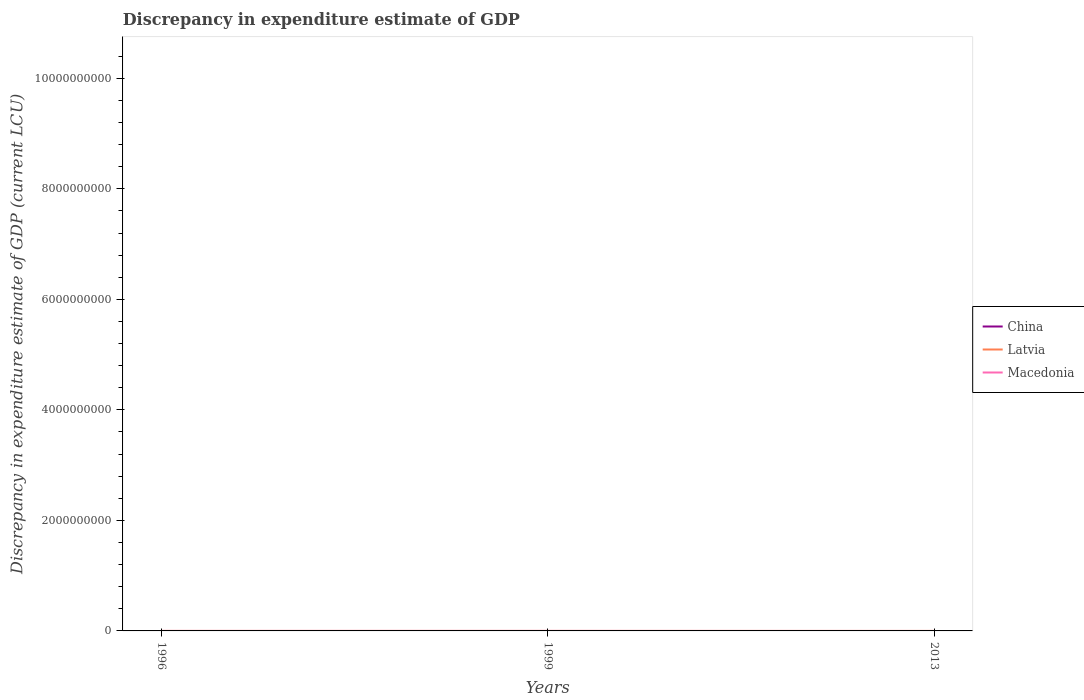How many different coloured lines are there?
Provide a succinct answer. 2. Is the number of lines equal to the number of legend labels?
Provide a short and direct response. No. Across all years, what is the maximum discrepancy in expenditure estimate of GDP in China?
Provide a short and direct response. 0. What is the difference between the highest and the second highest discrepancy in expenditure estimate of GDP in Latvia?
Provide a succinct answer. 1000. What is the difference between the highest and the lowest discrepancy in expenditure estimate of GDP in China?
Provide a succinct answer. 0. How many lines are there?
Give a very brief answer. 2. How many years are there in the graph?
Make the answer very short. 3. Are the values on the major ticks of Y-axis written in scientific E-notation?
Give a very brief answer. No. Does the graph contain any zero values?
Your answer should be very brief. Yes. What is the title of the graph?
Offer a terse response. Discrepancy in expenditure estimate of GDP. Does "Cuba" appear as one of the legend labels in the graph?
Provide a short and direct response. No. What is the label or title of the X-axis?
Your answer should be very brief. Years. What is the label or title of the Y-axis?
Your answer should be very brief. Discrepancy in expenditure estimate of GDP (current LCU). What is the Discrepancy in expenditure estimate of GDP (current LCU) in China in 1996?
Offer a terse response. 0. What is the Discrepancy in expenditure estimate of GDP (current LCU) of Macedonia in 1996?
Ensure brevity in your answer.  0. What is the Discrepancy in expenditure estimate of GDP (current LCU) in China in 1999?
Offer a very short reply. 0. What is the Discrepancy in expenditure estimate of GDP (current LCU) in Latvia in 1999?
Your response must be concise. 1000. What is the Discrepancy in expenditure estimate of GDP (current LCU) in Macedonia in 1999?
Provide a short and direct response. 1.63e+05. What is the Discrepancy in expenditure estimate of GDP (current LCU) in Macedonia in 2013?
Provide a short and direct response. 0. Across all years, what is the maximum Discrepancy in expenditure estimate of GDP (current LCU) of Latvia?
Ensure brevity in your answer.  1000. Across all years, what is the maximum Discrepancy in expenditure estimate of GDP (current LCU) in Macedonia?
Offer a terse response. 1.63e+05. Across all years, what is the minimum Discrepancy in expenditure estimate of GDP (current LCU) of Latvia?
Provide a short and direct response. 0. What is the total Discrepancy in expenditure estimate of GDP (current LCU) of China in the graph?
Ensure brevity in your answer.  0. What is the total Discrepancy in expenditure estimate of GDP (current LCU) in Macedonia in the graph?
Ensure brevity in your answer.  1.63e+05. What is the average Discrepancy in expenditure estimate of GDP (current LCU) in Latvia per year?
Make the answer very short. 333.33. What is the average Discrepancy in expenditure estimate of GDP (current LCU) of Macedonia per year?
Ensure brevity in your answer.  5.45e+04. In the year 1999, what is the difference between the Discrepancy in expenditure estimate of GDP (current LCU) in Latvia and Discrepancy in expenditure estimate of GDP (current LCU) in Macedonia?
Provide a short and direct response. -1.62e+05. What is the difference between the highest and the lowest Discrepancy in expenditure estimate of GDP (current LCU) of Macedonia?
Your response must be concise. 1.63e+05. 